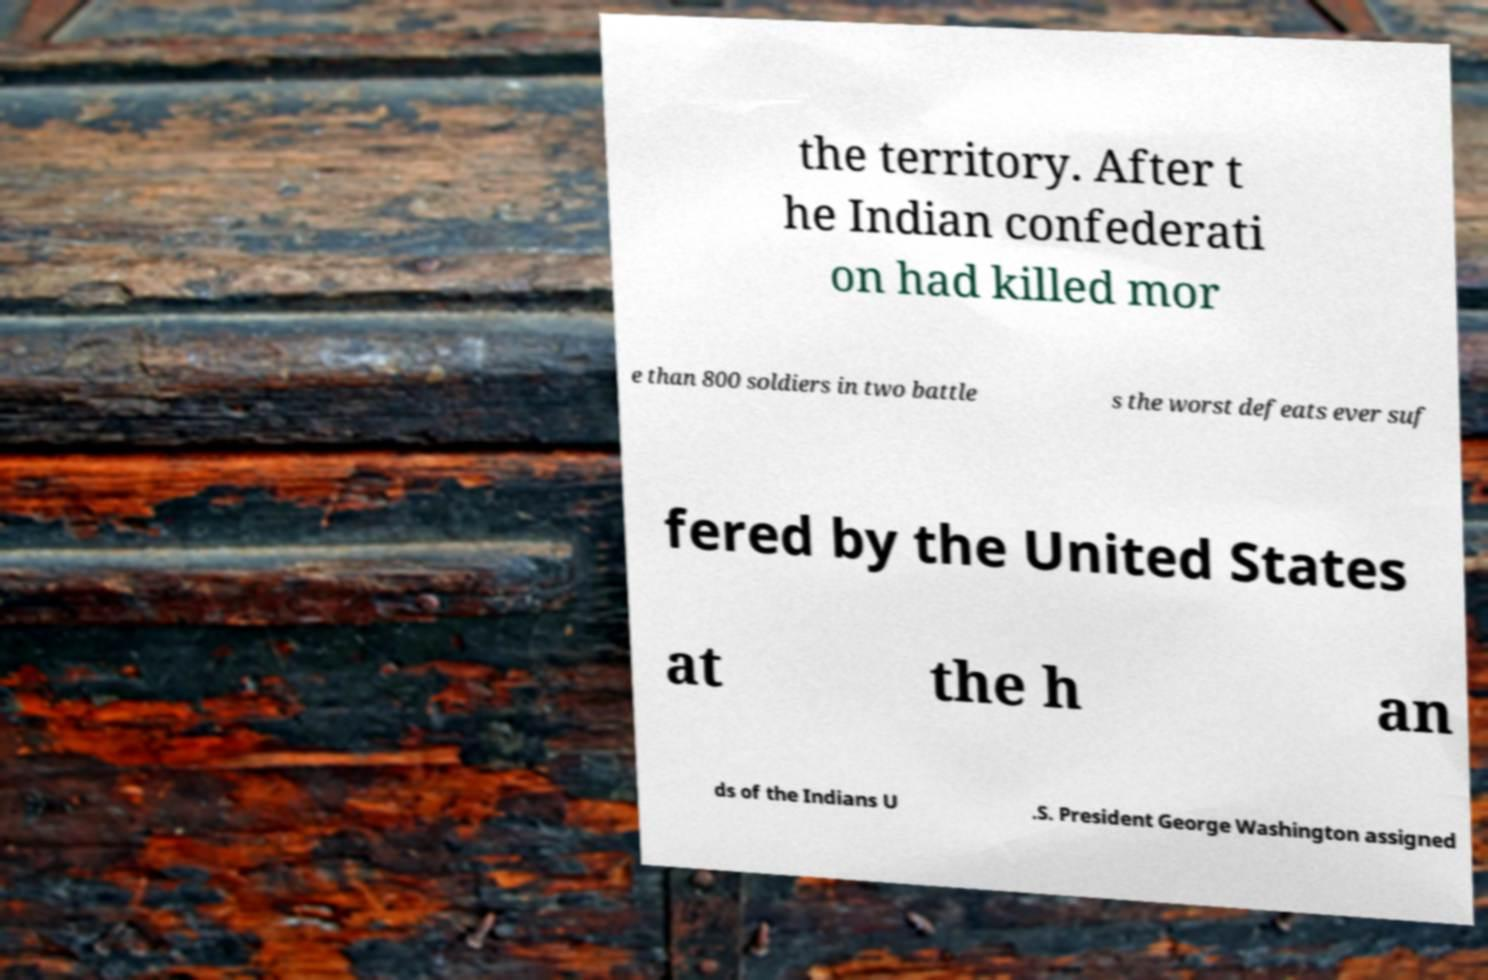For documentation purposes, I need the text within this image transcribed. Could you provide that? the territory. After t he Indian confederati on had killed mor e than 800 soldiers in two battle s the worst defeats ever suf fered by the United States at the h an ds of the Indians U .S. President George Washington assigned 